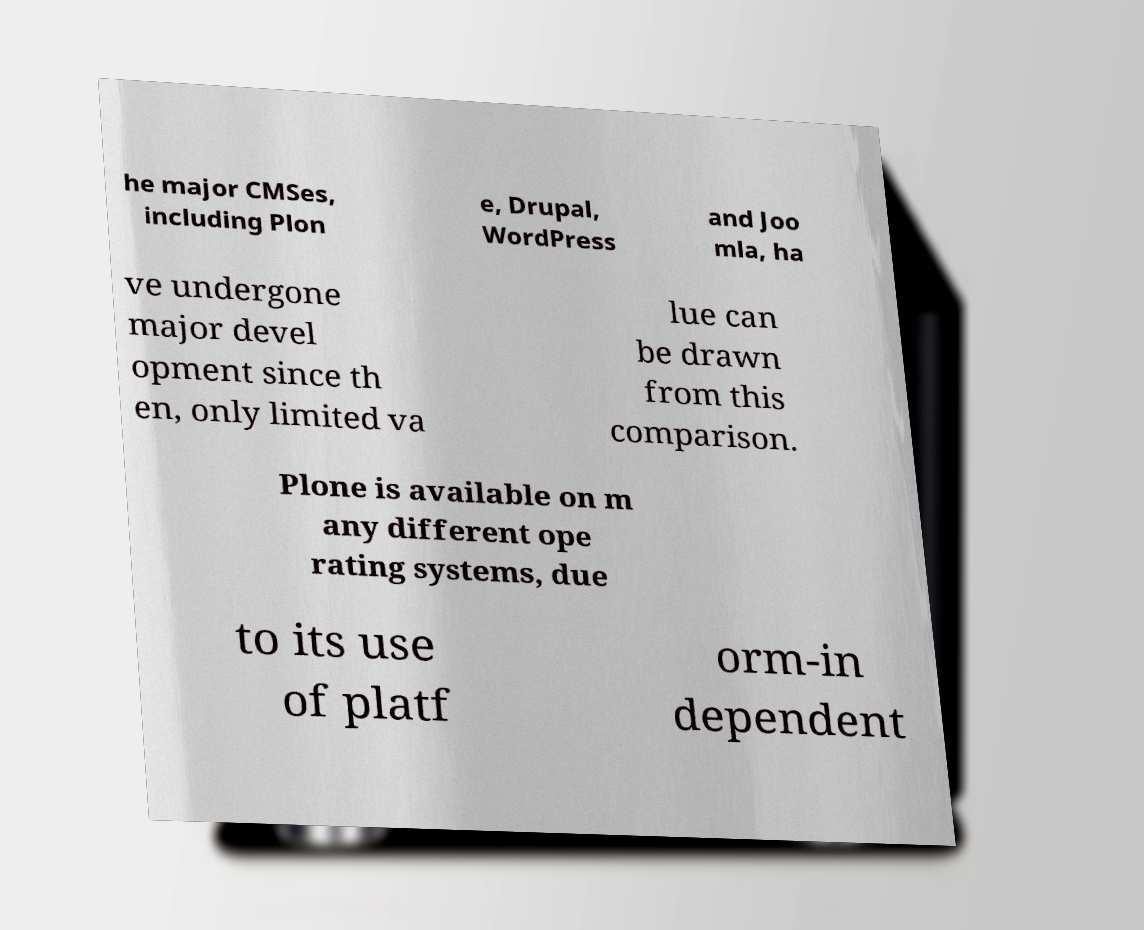Could you assist in decoding the text presented in this image and type it out clearly? he major CMSes, including Plon e, Drupal, WordPress and Joo mla, ha ve undergone major devel opment since th en, only limited va lue can be drawn from this comparison. Plone is available on m any different ope rating systems, due to its use of platf orm-in dependent 